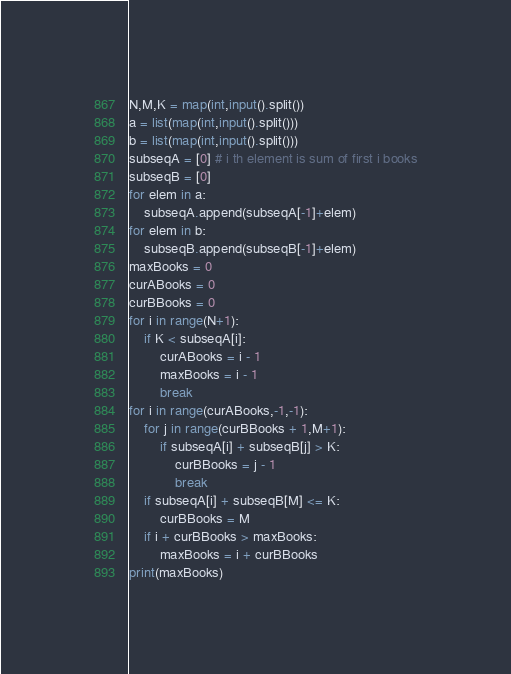<code> <loc_0><loc_0><loc_500><loc_500><_Python_>N,M,K = map(int,input().split())
a = list(map(int,input().split()))
b = list(map(int,input().split()))
subseqA = [0] # i th element is sum of first i books
subseqB = [0]
for elem in a:
    subseqA.append(subseqA[-1]+elem)
for elem in b:
    subseqB.append(subseqB[-1]+elem)
maxBooks = 0
curABooks = 0
curBBooks = 0
for i in range(N+1):
    if K < subseqA[i]:
        curABooks = i - 1
        maxBooks = i - 1
        break
for i in range(curABooks,-1,-1):
    for j in range(curBBooks + 1,M+1):
        if subseqA[i] + subseqB[j] > K:
            curBBooks = j - 1
            break
    if subseqA[i] + subseqB[M] <= K:
        curBBooks = M
    if i + curBBooks > maxBooks:
        maxBooks = i + curBBooks
print(maxBooks)</code> 